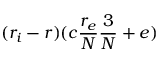<formula> <loc_0><loc_0><loc_500><loc_500>( r _ { i } - r ) ( c \frac { r _ { e } } { N } \frac { 3 } { N } + e )</formula> 